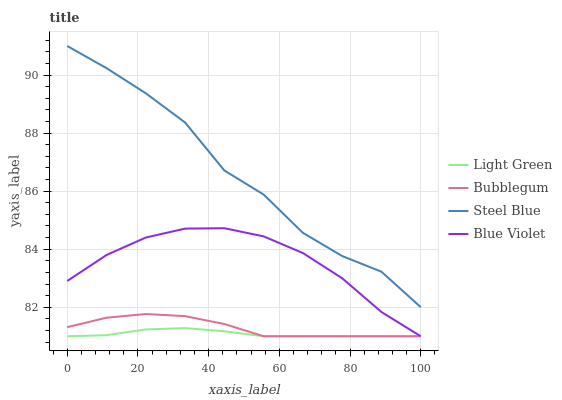Does Light Green have the minimum area under the curve?
Answer yes or no. Yes. Does Steel Blue have the maximum area under the curve?
Answer yes or no. Yes. Does Bubblegum have the minimum area under the curve?
Answer yes or no. No. Does Bubblegum have the maximum area under the curve?
Answer yes or no. No. Is Light Green the smoothest?
Answer yes or no. Yes. Is Steel Blue the roughest?
Answer yes or no. Yes. Is Bubblegum the smoothest?
Answer yes or no. No. Is Bubblegum the roughest?
Answer yes or no. No. Does Blue Violet have the lowest value?
Answer yes or no. Yes. Does Steel Blue have the lowest value?
Answer yes or no. No. Does Steel Blue have the highest value?
Answer yes or no. Yes. Does Bubblegum have the highest value?
Answer yes or no. No. Is Blue Violet less than Steel Blue?
Answer yes or no. Yes. Is Steel Blue greater than Blue Violet?
Answer yes or no. Yes. Does Light Green intersect Blue Violet?
Answer yes or no. Yes. Is Light Green less than Blue Violet?
Answer yes or no. No. Is Light Green greater than Blue Violet?
Answer yes or no. No. Does Blue Violet intersect Steel Blue?
Answer yes or no. No. 